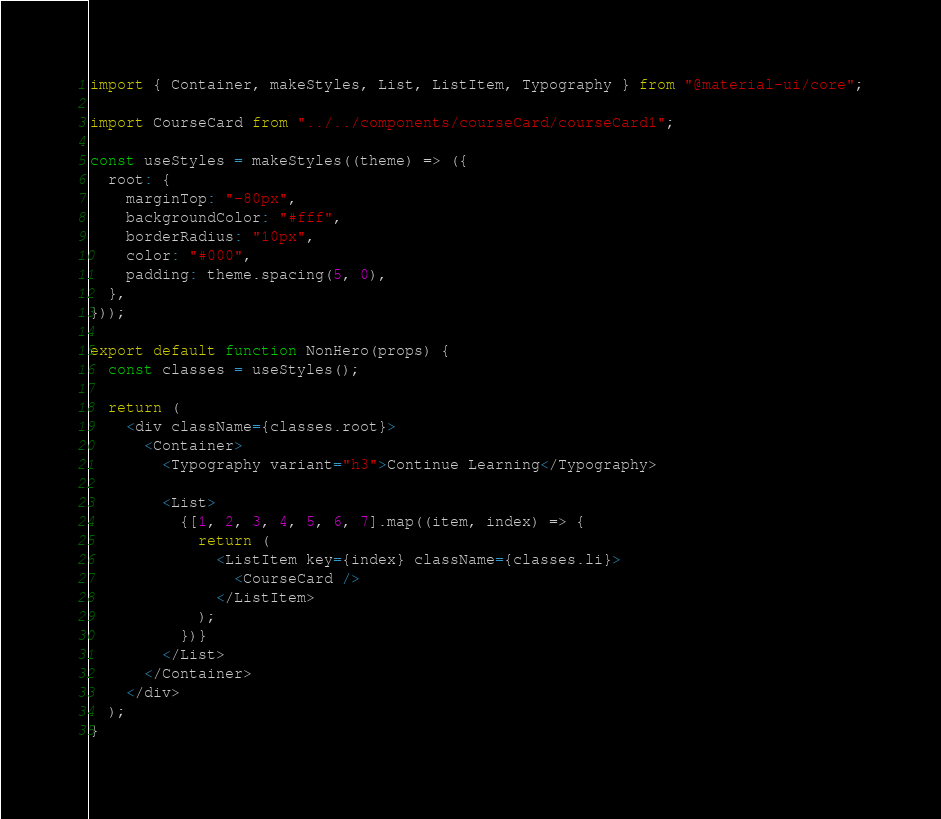<code> <loc_0><loc_0><loc_500><loc_500><_JavaScript_>import { Container, makeStyles, List, ListItem, Typography } from "@material-ui/core";

import CourseCard from "../../components/courseCard/courseCard1";

const useStyles = makeStyles((theme) => ({
  root: {
    marginTop: "-80px",
    backgroundColor: "#fff",
    borderRadius: "10px",
    color: "#000",
    padding: theme.spacing(5, 0),
  },
}));

export default function NonHero(props) {
  const classes = useStyles();

  return (
    <div className={classes.root}>
      <Container>
        <Typography variant="h3">Continue Learning</Typography>

        <List>
          {[1, 2, 3, 4, 5, 6, 7].map((item, index) => {
            return (
              <ListItem key={index} className={classes.li}>
                <CourseCard />
              </ListItem>
            );
          })}
        </List>
      </Container>
    </div>
  );
}
</code> 